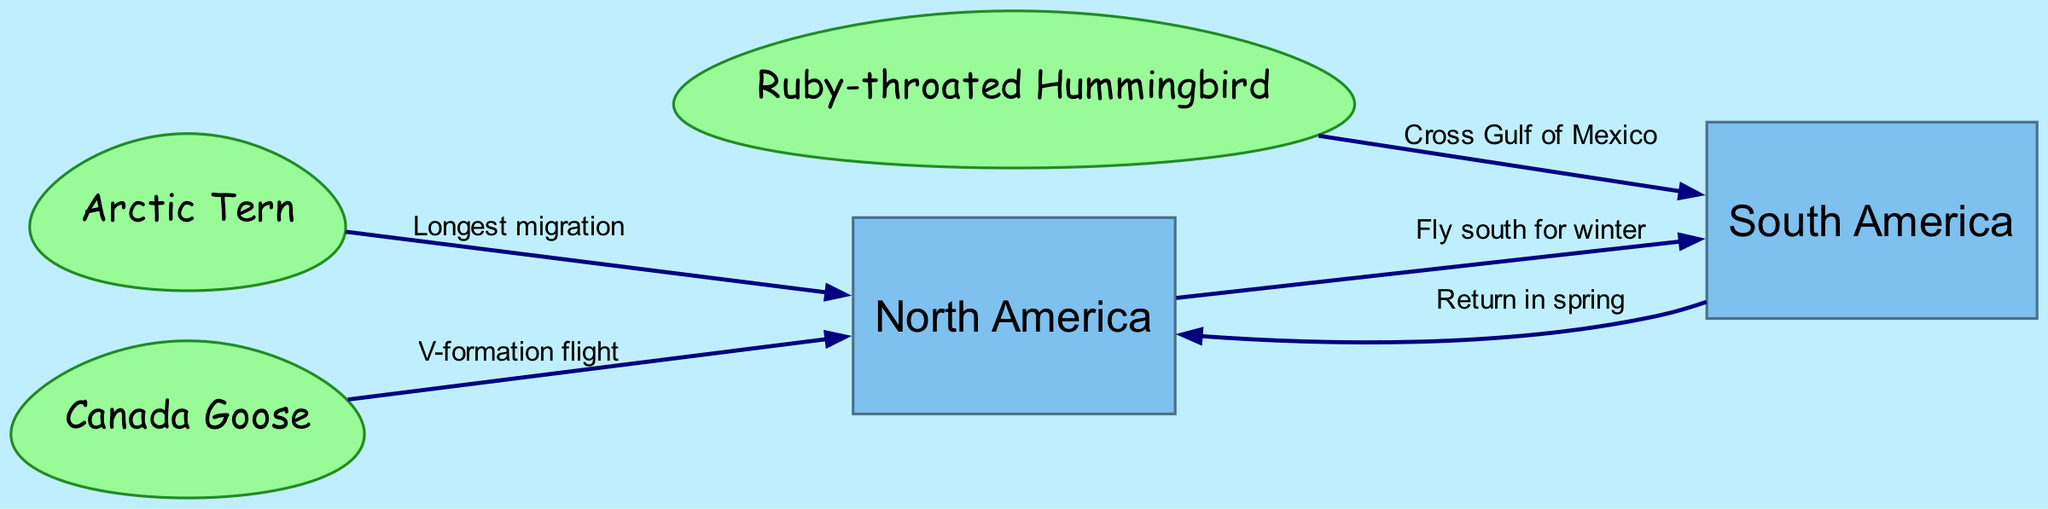What are the bird species involved in migrations represented in the diagram? The diagram shows three bird species: Arctic Tern, Canada Goose, and Ruby-throated Hummingbird. Each one is linked to migration patterns connecting North America and South America.
Answer: Arctic Tern, Canada Goose, Ruby-throated Hummingbird How many nodes are there in the diagram? The diagram consists of five nodes: two continents (North America and South America) and three bird species (Arctic Tern, Canada Goose, and Ruby-throated Hummingbird). Counting these gives a total of five nodes.
Answer: 5 Which bird species migrates the longest distance? The diagram indicates that the Arctic Tern is associated with the label "Longest migration," suggesting it migrates the farthest distance among the species depicted.
Answer: Arctic Tern What is the migration flight formation of the Canada Goose? The edge connecting Canada Goose to North America mentions "V-formation flight," which specifies the type of flight formation Canada Geese use during migration.
Answer: V-formation flight From which continent does the Ruby-throated Hummingbird migrate south? The diagram shows an edge from the Ruby-throated Hummingbird to South America, indicating that it migrates south from North America.
Answer: North America What migration route is taken by many birds to go from North America to South America during winter? The edge from North America to South America in the diagram describes the migration route with the label "Fly south for winter," indicating the typical movement of birds during this season.
Answer: Fly south for winter How do birds return from South America to North America? The diagram shows an edge from South America to North America with the label "Return in spring," indicating that the birds return back to North America during the spring season.
Answer: Return in spring How many edges connect the bird species to the continents? There are four edges connecting the bird species to the continents: one for each bird species in their respective migration paths. This is calculated by counting the edges labeled with the bird names connecting to North America and South America.
Answer: 4 